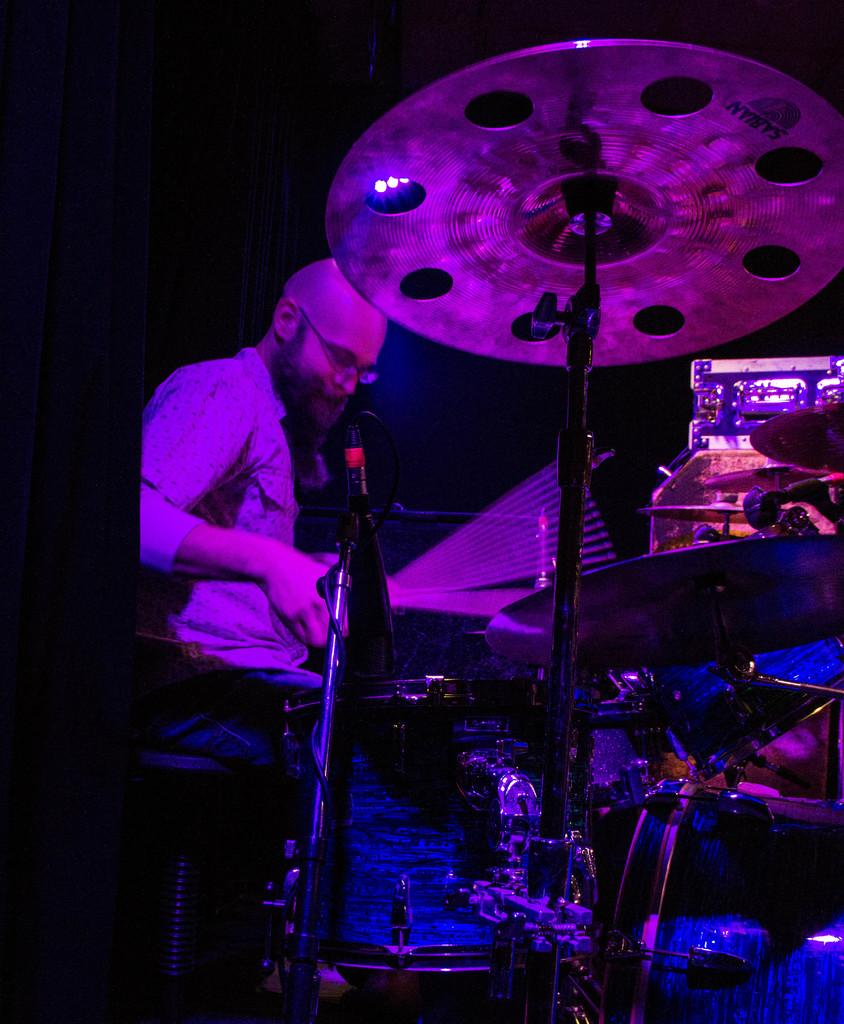What is the person in the image doing? The person is sitting on a chair and playing music. What might be the person using to play the music? There are musical instruments in front of the person, which they be using to play music? Can you describe the person's posture in the image? The person is likely sitting comfortably on the chair while playing the music. What type of regret can be seen on the person's face in the image? There is no indication of regret on the person's face in the image; they appear to be focused on playing music. 